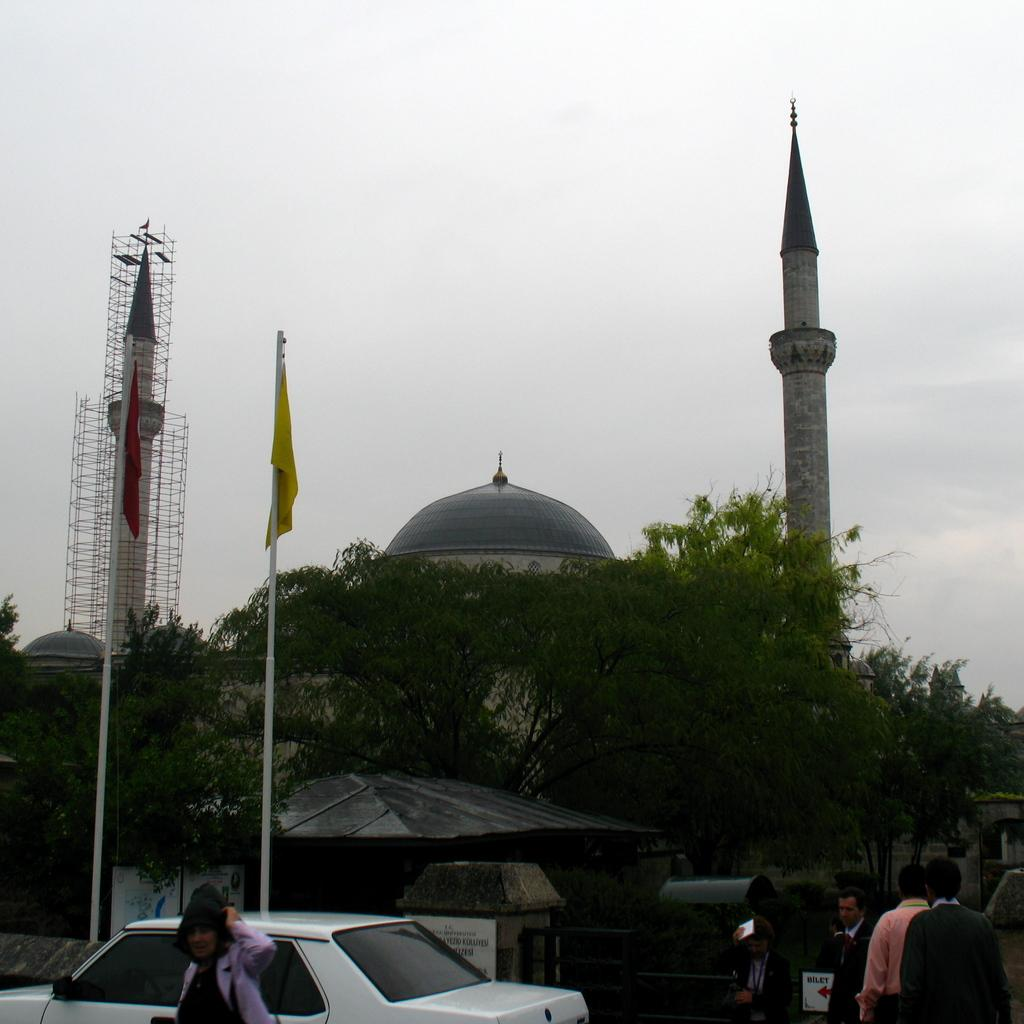What color is the car in the image? The car in the image is white. What are the people in the image doing? People are walking on the road in the image. What can be seen in the background of the image? There are flagpoles, trees, towers, and the sky visible in the background of the image. What type of spark can be seen coming from the car in the image? There is no spark coming from the car in the image. 